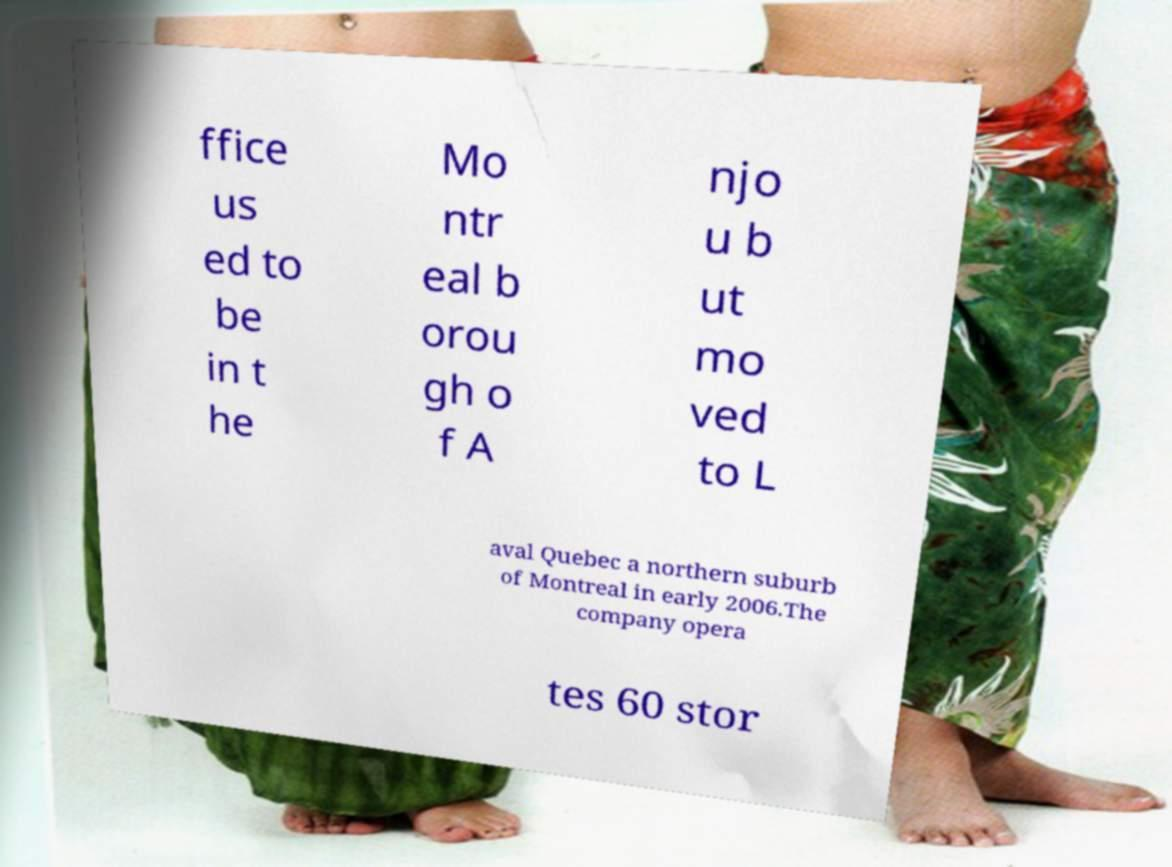Could you extract and type out the text from this image? ffice us ed to be in t he Mo ntr eal b orou gh o f A njo u b ut mo ved to L aval Quebec a northern suburb of Montreal in early 2006.The company opera tes 60 stor 